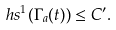Convert formula to latex. <formula><loc_0><loc_0><loc_500><loc_500>\ h s ^ { 1 } ( \Gamma _ { a } ( t ) ) \leq C ^ { \prime } .</formula> 